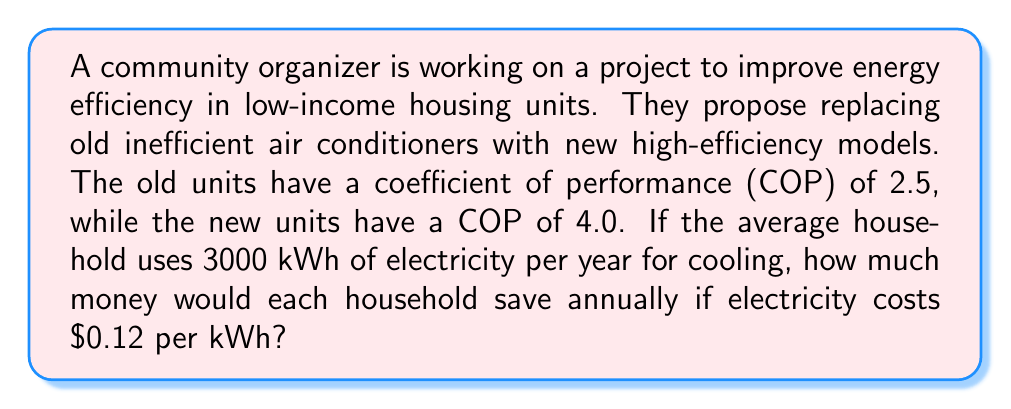Show me your answer to this math problem. Let's approach this problem step-by-step using thermodynamic principles:

1) The Coefficient of Performance (COP) is defined as:

   $$ COP = \frac{Q_c}{W} $$

   Where $Q_c$ is the heat removed from the cold reservoir (the house), and $W$ is the work input (electrical energy).

2) For the old units:
   $$ COP_{old} = 2.5 = \frac{Q_c}{W_{old}} $$

3) For the new units:
   $$ COP_{new} = 4.0 = \frac{Q_c}{W_{new}} $$

4) The heat removed ($Q_c$) is the same in both cases, as it depends on the cooling needs of the house. We can set this as our reference:
   $$ Q_c = 2.5W_{old} = 4.0W_{new} $$

5) The annual electricity usage with the old units is given (3000 kWh). So:
   $$ W_{old} = 3000 \text{ kWh} $$

6) We can now calculate the work input for the new units:
   $$ W_{new} = \frac{2.5}{4.0} W_{old} = \frac{2.5}{4.0} \cdot 3000 = 1875 \text{ kWh} $$

7) The energy saved annually is:
   $$ W_{saved} = W_{old} - W_{new} = 3000 - 1875 = 1125 \text{ kWh} $$

8) To calculate the money saved, we multiply by the cost per kWh:
   $$ \text{Money saved} = 1125 \text{ kWh} \cdot \$0.12/\text{kWh} = \$135 $$

Therefore, each household would save $135 annually.
Answer: $135 